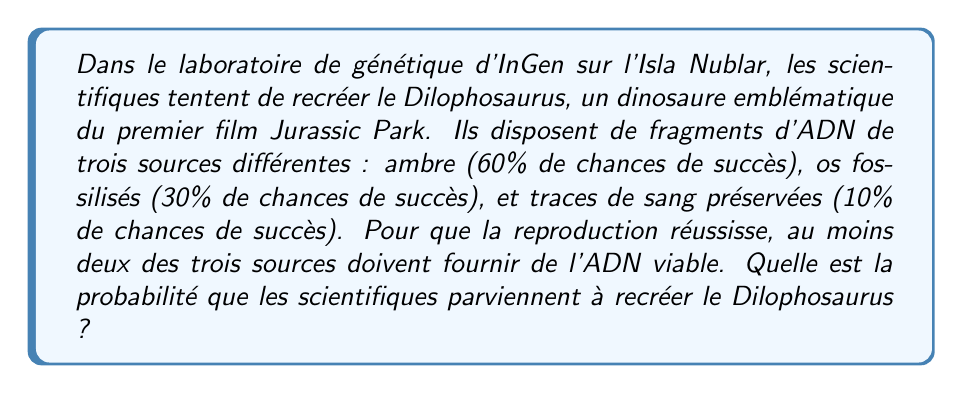Give your solution to this math problem. Pour résoudre ce problème, nous allons utiliser la théorie des probabilités.

Étape 1 : Définissons les événements
A : Succès avec l'ADN de l'ambre (P(A) = 0.60)
B : Succès avec l'ADN des os fossilisés (P(B) = 0.30)
C : Succès avec l'ADN des traces de sang (P(C) = 0.10)

Étape 2 : Calculons la probabilité de réussite
La réussite survient lorsqu'au moins deux des trois sources fournissent de l'ADN viable. Nous pouvons calculer cela en soustrayant la probabilité qu'aucune ou une seule source ne réussisse de 1.

P(réussite) = 1 - P(échec total ou une seule réussite)

Étape 3 : Calculons les probabilités d'échec
P(échec A) = 1 - 0.60 = 0.40
P(échec B) = 1 - 0.30 = 0.70
P(échec C) = 1 - 0.10 = 0.90

Étape 4 : Calculons la probabilité d'échec total
P(échec total) = 0.40 * 0.70 * 0.90 = 0.252

Étape 5 : Calculons les probabilités de réussite unique
P(A réussit seul) = 0.60 * 0.70 * 0.90 = 0.378
P(B réussit seul) = 0.40 * 0.30 * 0.90 = 0.108
P(C réussit seul) = 0.40 * 0.70 * 0.10 = 0.028

Étape 6 : Sommons les probabilités d'échec total et de réussite unique
P(échec total ou une seule réussite) = 0.252 + 0.378 + 0.108 + 0.028 = 0.766

Étape 7 : Calculons la probabilité finale de réussite
P(réussite) = 1 - 0.766 = 0.234

Donc, la probabilité de réussir à recréer le Dilophosaurus est de 0.234 ou 23.4%.
Answer: 0.234 ou 23.4% 